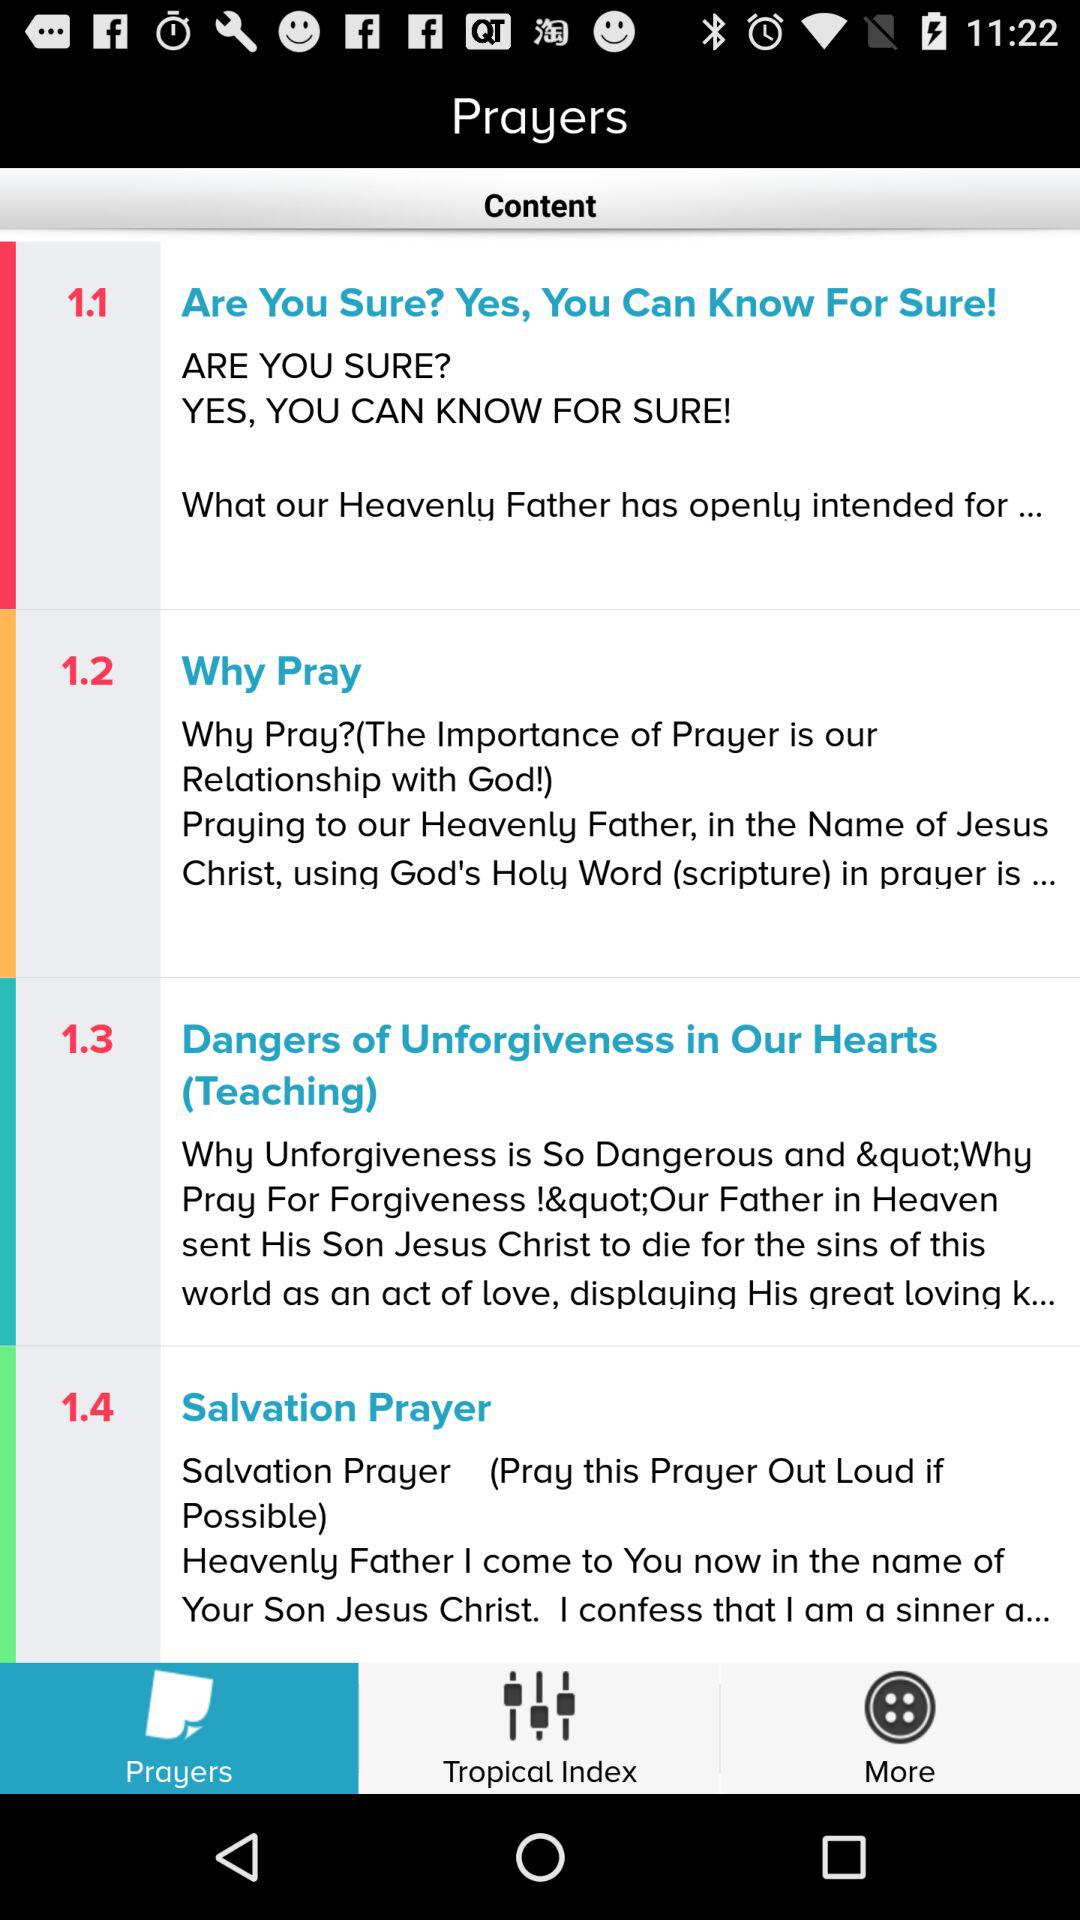What is the selected tab? The selected tab is "Prayers". 